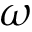<formula> <loc_0><loc_0><loc_500><loc_500>\omega</formula> 